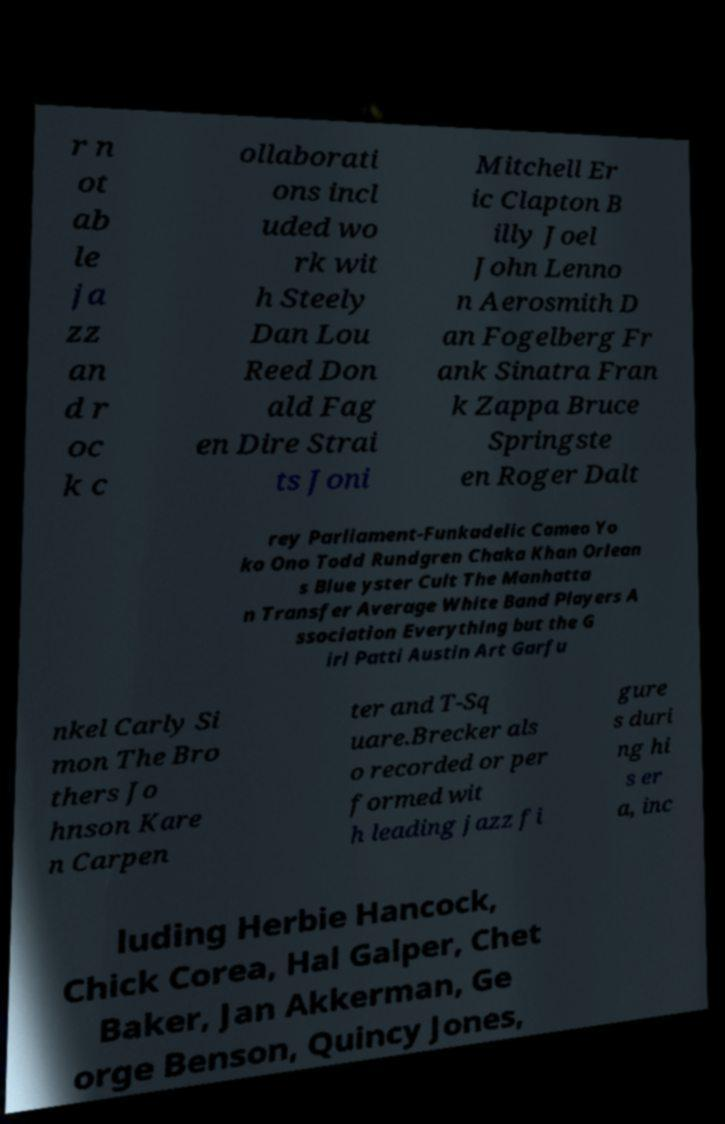Could you extract and type out the text from this image? r n ot ab le ja zz an d r oc k c ollaborati ons incl uded wo rk wit h Steely Dan Lou Reed Don ald Fag en Dire Strai ts Joni Mitchell Er ic Clapton B illy Joel John Lenno n Aerosmith D an Fogelberg Fr ank Sinatra Fran k Zappa Bruce Springste en Roger Dalt rey Parliament-Funkadelic Cameo Yo ko Ono Todd Rundgren Chaka Khan Orlean s Blue yster Cult The Manhatta n Transfer Average White Band Players A ssociation Everything but the G irl Patti Austin Art Garfu nkel Carly Si mon The Bro thers Jo hnson Kare n Carpen ter and T-Sq uare.Brecker als o recorded or per formed wit h leading jazz fi gure s duri ng hi s er a, inc luding Herbie Hancock, Chick Corea, Hal Galper, Chet Baker, Jan Akkerman, Ge orge Benson, Quincy Jones, 